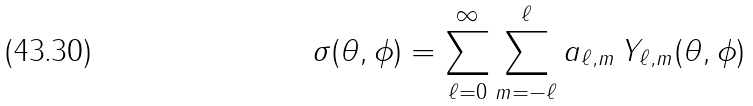Convert formula to latex. <formula><loc_0><loc_0><loc_500><loc_500>\sigma ( \theta , \phi ) = \sum _ { \ell = 0 } ^ { \infty } \sum _ { m = - \ell } ^ { \ell } a _ { \ell , m } \, Y _ { \ell , m } ( \theta , \phi )</formula> 